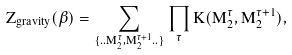<formula> <loc_0><loc_0><loc_500><loc_500>Z _ { g r a v i t y } ( \beta ) = \sum _ { \{ . . M ^ { \tau } _ { 2 } , M ^ { \tau + 1 } _ { 2 } . . \} } \prod _ { \tau } K ( M ^ { \tau } _ { 2 } , M ^ { \tau + 1 } _ { 2 } ) ,</formula> 